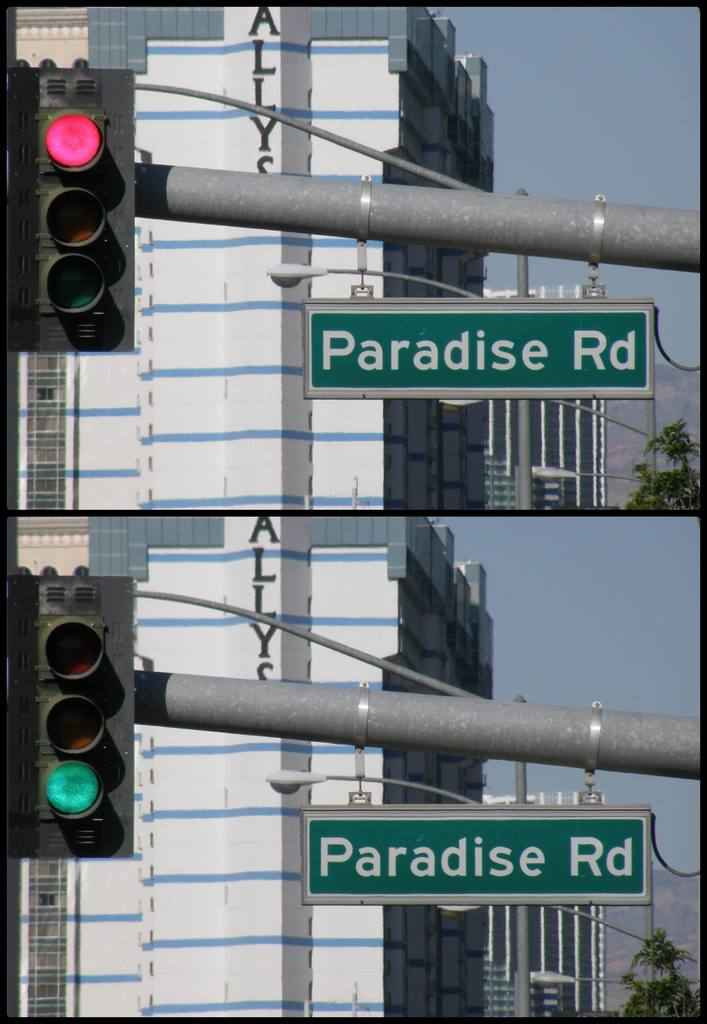Can you tell me more about the buildings visible behind the road signs? The buildings behind the road signs are modern and likely part of a commercial area. They feature reflective glass facades which suggest they might house offices or businesses integral to a bustling urban center. 